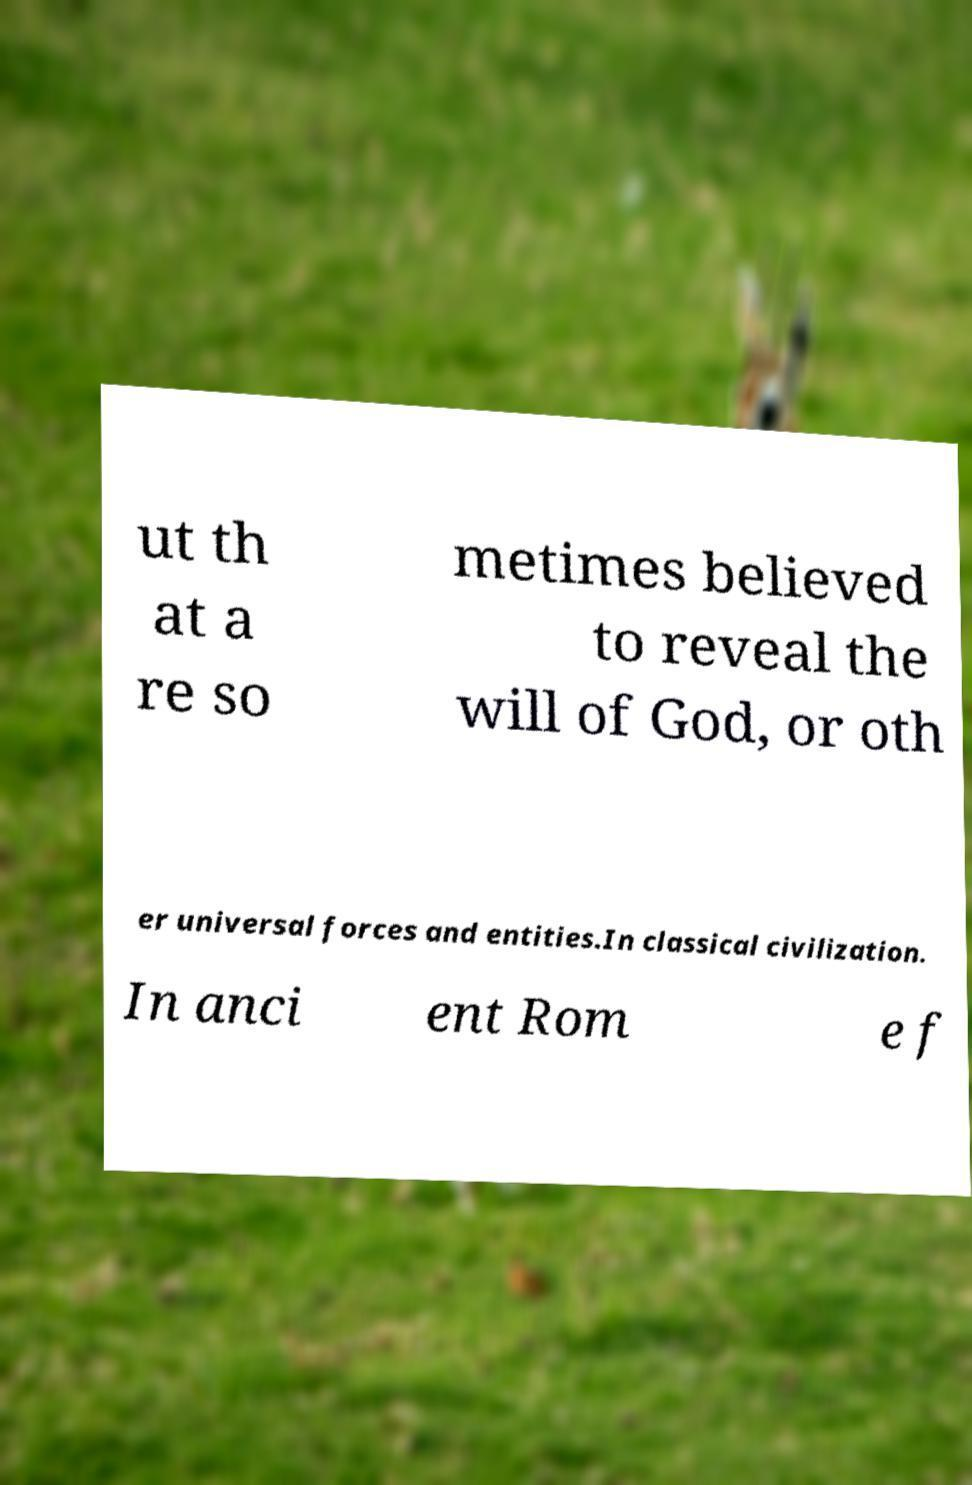Can you read and provide the text displayed in the image?This photo seems to have some interesting text. Can you extract and type it out for me? ut th at a re so metimes believed to reveal the will of God, or oth er universal forces and entities.In classical civilization. In anci ent Rom e f 